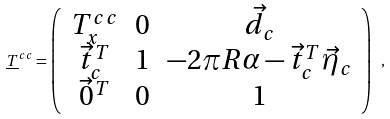Convert formula to latex. <formula><loc_0><loc_0><loc_500><loc_500>\underline { T } ^ { c c } = \left ( \begin{array} { c c c } T ^ { c c } _ { x } & 0 & \vec { d } _ { c } \\ \vec { t } _ { c } ^ { T } & 1 & - 2 \pi R \alpha - \vec { t } _ { c } ^ { T } \vec { \eta } _ { c } \\ \vec { 0 } ^ { T } & 0 & 1 \end{array} \right ) \ ,</formula> 